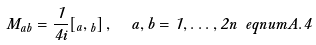<formula> <loc_0><loc_0><loc_500><loc_500>M _ { a b } = \frac { 1 } { 4 i } [ \Gamma _ { a } , \Gamma _ { b } ] \, , \ \ a , b = 1 , \dots , 2 n \ e q n u m { A . 4 }</formula> 